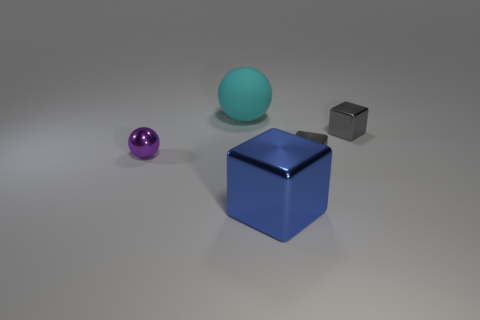Subtract all blue cylinders. How many gray blocks are left? 2 Subtract all tiny cubes. How many cubes are left? 1 Subtract 1 cubes. How many cubes are left? 2 Add 1 large blue cubes. How many objects exist? 6 Subtract all blocks. How many objects are left? 2 Add 2 large rubber balls. How many large rubber balls are left? 3 Add 5 big red matte blocks. How many big red matte blocks exist? 5 Subtract 0 yellow balls. How many objects are left? 5 Subtract all small yellow rubber things. Subtract all small gray metallic objects. How many objects are left? 3 